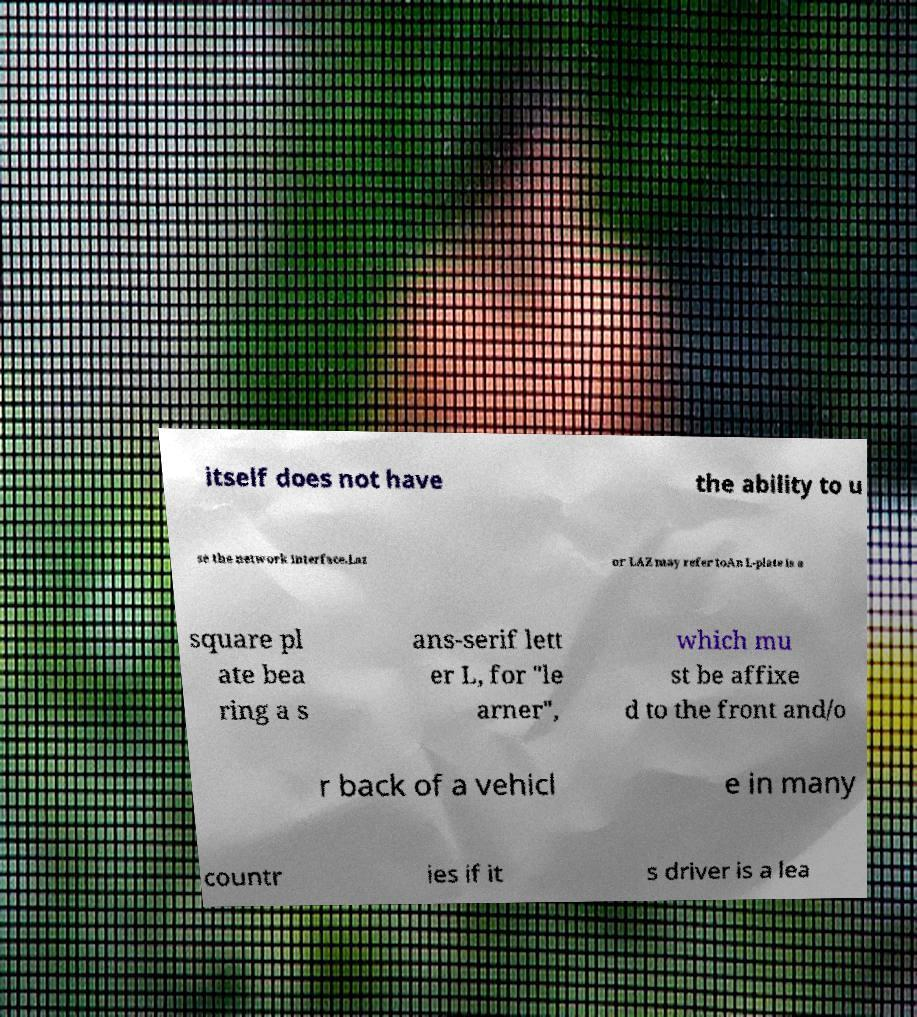Please read and relay the text visible in this image. What does it say? itself does not have the ability to u se the network interface.Laz or LAZ may refer toAn L-plate is a square pl ate bea ring a s ans-serif lett er L, for "le arner", which mu st be affixe d to the front and/o r back of a vehicl e in many countr ies if it s driver is a lea 